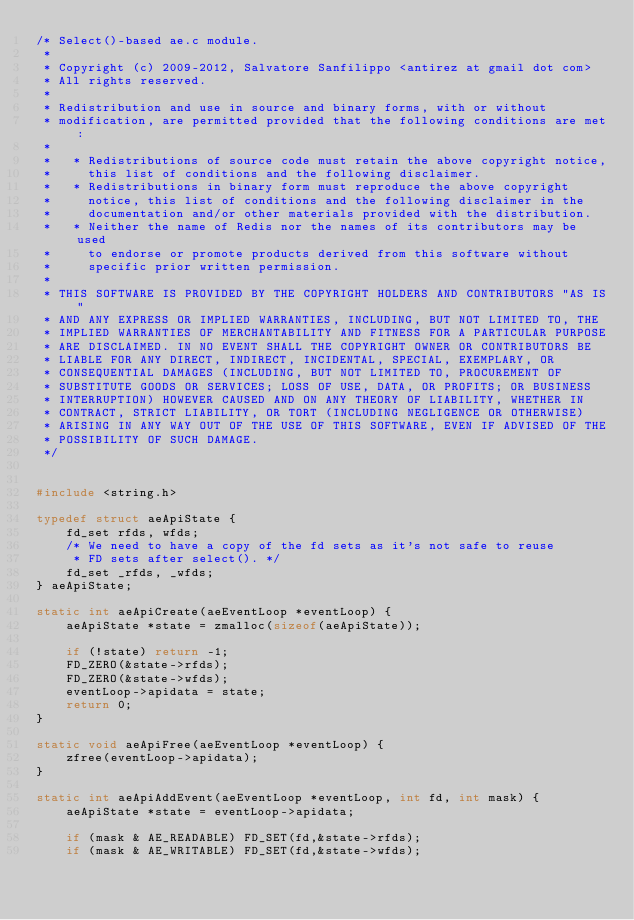<code> <loc_0><loc_0><loc_500><loc_500><_C_>/* Select()-based ae.c module.
 *
 * Copyright (c) 2009-2012, Salvatore Sanfilippo <antirez at gmail dot com>
 * All rights reserved.
 *
 * Redistribution and use in source and binary forms, with or without
 * modification, are permitted provided that the following conditions are met:
 *
 *   * Redistributions of source code must retain the above copyright notice,
 *     this list of conditions and the following disclaimer.
 *   * Redistributions in binary form must reproduce the above copyright
 *     notice, this list of conditions and the following disclaimer in the
 *     documentation and/or other materials provided with the distribution.
 *   * Neither the name of Redis nor the names of its contributors may be used
 *     to endorse or promote products derived from this software without
 *     specific prior written permission.
 *
 * THIS SOFTWARE IS PROVIDED BY THE COPYRIGHT HOLDERS AND CONTRIBUTORS "AS IS"
 * AND ANY EXPRESS OR IMPLIED WARRANTIES, INCLUDING, BUT NOT LIMITED TO, THE
 * IMPLIED WARRANTIES OF MERCHANTABILITY AND FITNESS FOR A PARTICULAR PURPOSE
 * ARE DISCLAIMED. IN NO EVENT SHALL THE COPYRIGHT OWNER OR CONTRIBUTORS BE
 * LIABLE FOR ANY DIRECT, INDIRECT, INCIDENTAL, SPECIAL, EXEMPLARY, OR
 * CONSEQUENTIAL DAMAGES (INCLUDING, BUT NOT LIMITED TO, PROCUREMENT OF
 * SUBSTITUTE GOODS OR SERVICES; LOSS OF USE, DATA, OR PROFITS; OR BUSINESS
 * INTERRUPTION) HOWEVER CAUSED AND ON ANY THEORY OF LIABILITY, WHETHER IN
 * CONTRACT, STRICT LIABILITY, OR TORT (INCLUDING NEGLIGENCE OR OTHERWISE)
 * ARISING IN ANY WAY OUT OF THE USE OF THIS SOFTWARE, EVEN IF ADVISED OF THE
 * POSSIBILITY OF SUCH DAMAGE.
 */


#include <string.h>

typedef struct aeApiState {
    fd_set rfds, wfds;
    /* We need to have a copy of the fd sets as it's not safe to reuse
     * FD sets after select(). */
    fd_set _rfds, _wfds;
} aeApiState;

static int aeApiCreate(aeEventLoop *eventLoop) {
    aeApiState *state = zmalloc(sizeof(aeApiState));

    if (!state) return -1;
    FD_ZERO(&state->rfds);
    FD_ZERO(&state->wfds);
    eventLoop->apidata = state;
    return 0;
}

static void aeApiFree(aeEventLoop *eventLoop) {
    zfree(eventLoop->apidata);
}

static int aeApiAddEvent(aeEventLoop *eventLoop, int fd, int mask) {
    aeApiState *state = eventLoop->apidata;

    if (mask & AE_READABLE) FD_SET(fd,&state->rfds);
    if (mask & AE_WRITABLE) FD_SET(fd,&state->wfds);</code> 